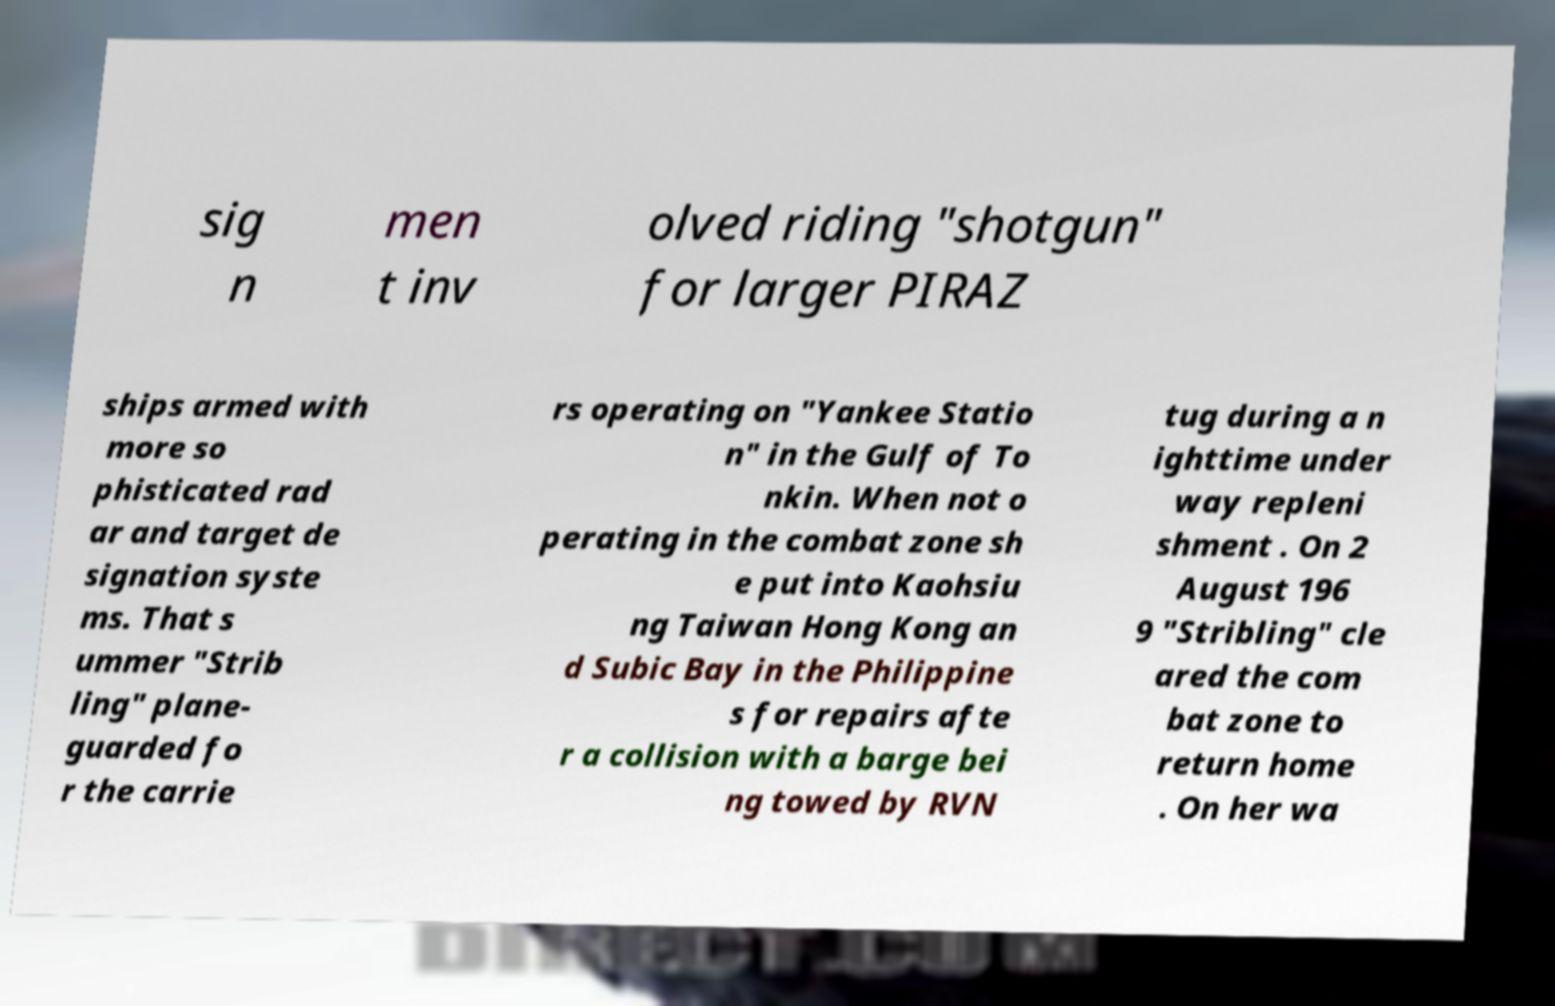Could you assist in decoding the text presented in this image and type it out clearly? sig n men t inv olved riding "shotgun" for larger PIRAZ ships armed with more so phisticated rad ar and target de signation syste ms. That s ummer "Strib ling" plane- guarded fo r the carrie rs operating on "Yankee Statio n" in the Gulf of To nkin. When not o perating in the combat zone sh e put into Kaohsiu ng Taiwan Hong Kong an d Subic Bay in the Philippine s for repairs afte r a collision with a barge bei ng towed by RVN tug during a n ighttime under way repleni shment . On 2 August 196 9 "Stribling" cle ared the com bat zone to return home . On her wa 